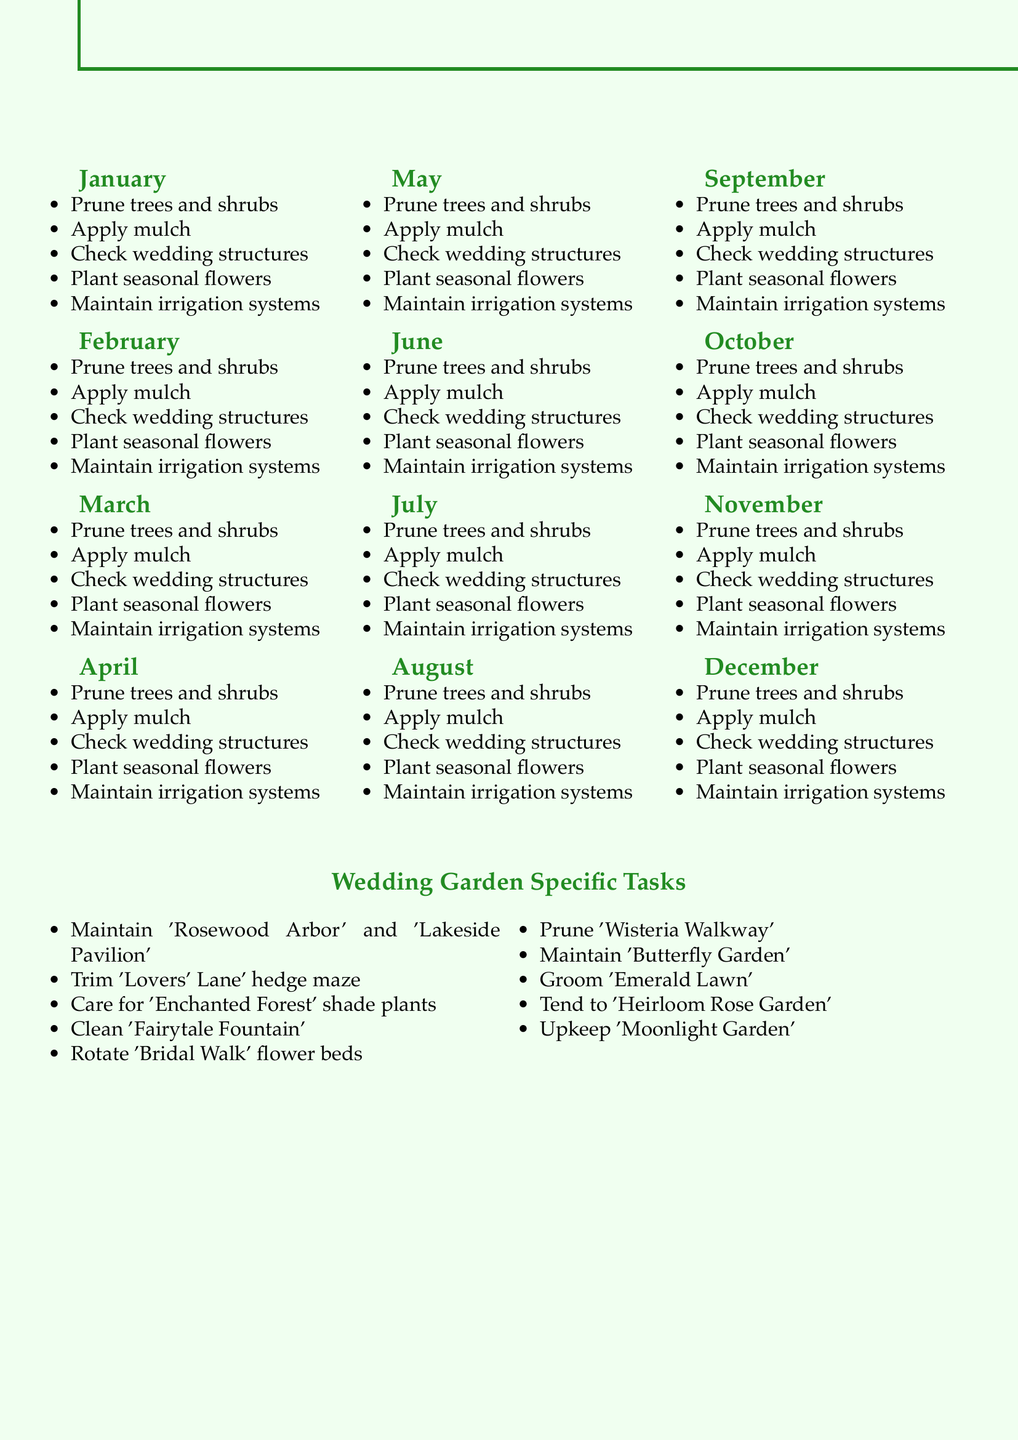What maintenance task is done in January? The document lists several tasks for January, including pruning dormant trees and applying winter mulch.
Answer: Prune dormant trees and shrubs How many tasks are listed for the month of April? In April, five specific tasks are mentioned, as per the document.
Answer: 5 What specific area is maintained monthly in the garden? The document specifies a maintenance task that involves shaping and trimming a specific hedge maze every month.
Answer: 'Lovers' Lane' hedge maze Which month involves planting warm-season annuals? The tasks for May specifically mention the planting of warm-season annuals.
Answer: May What is one task associated with the 'Butterfly Garden'? The document indicates that this garden should be maintained to attract pollinators.
Answer: Maintain 'Butterfly Garden' Which month requires the removal of winter mulch? The tasks for March include the removal of winter mulch to prepare for spring planting.
Answer: March How many wedding garden specific tasks are listed? The total number of specific tasks dedicated to the wedding garden is ten, as outlined in the document.
Answer: 10 What kind of flowers are to be planted in August? The document mentions planting fall-blooming bulbs during the month of August.
Answer: Fall-blooming bulbs Which area requires cleaning and maintenance of a fountain? The document specifies that the 'Fairytale Fountain' should be regularly cleaned and maintained.
Answer: 'Fairytale Fountain' 